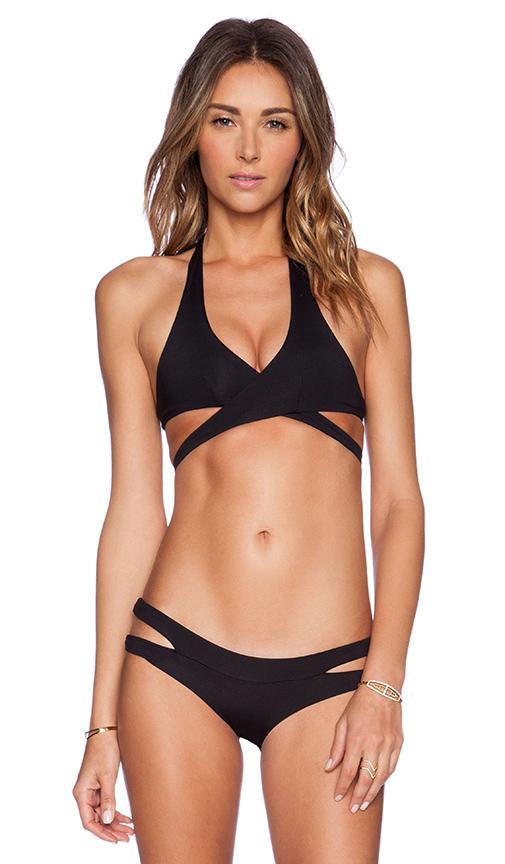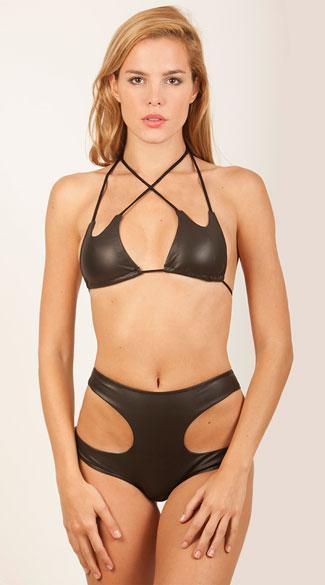The first image is the image on the left, the second image is the image on the right. For the images shown, is this caption "All bikinis shown are solid black." true? Answer yes or no. Yes. The first image is the image on the left, the second image is the image on the right. Assess this claim about the two images: "One of the images shows a woman near a swimming pool.". Correct or not? Answer yes or no. No. 